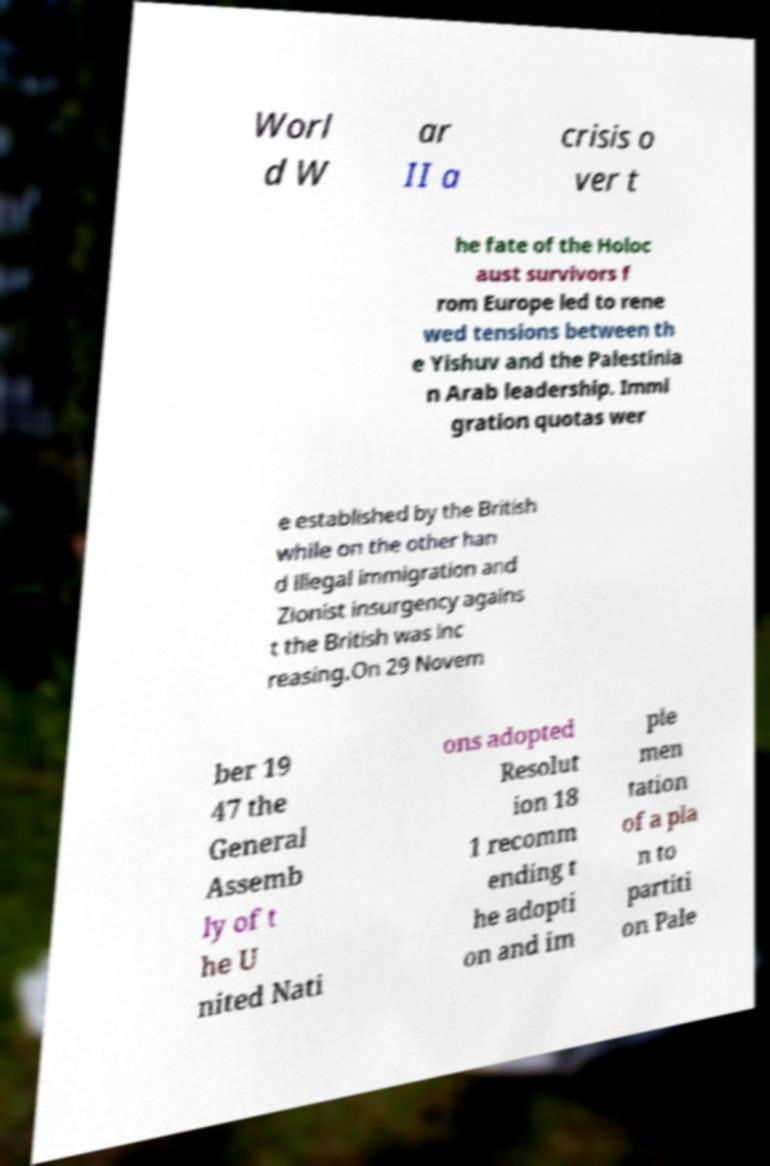Can you read and provide the text displayed in the image?This photo seems to have some interesting text. Can you extract and type it out for me? Worl d W ar II a crisis o ver t he fate of the Holoc aust survivors f rom Europe led to rene wed tensions between th e Yishuv and the Palestinia n Arab leadership. Immi gration quotas wer e established by the British while on the other han d illegal immigration and Zionist insurgency agains t the British was inc reasing.On 29 Novem ber 19 47 the General Assemb ly of t he U nited Nati ons adopted Resolut ion 18 1 recomm ending t he adopti on and im ple men tation of a pla n to partiti on Pale 